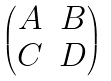Convert formula to latex. <formula><loc_0><loc_0><loc_500><loc_500>\begin{pmatrix} A & B \\ C & D \end{pmatrix}</formula> 